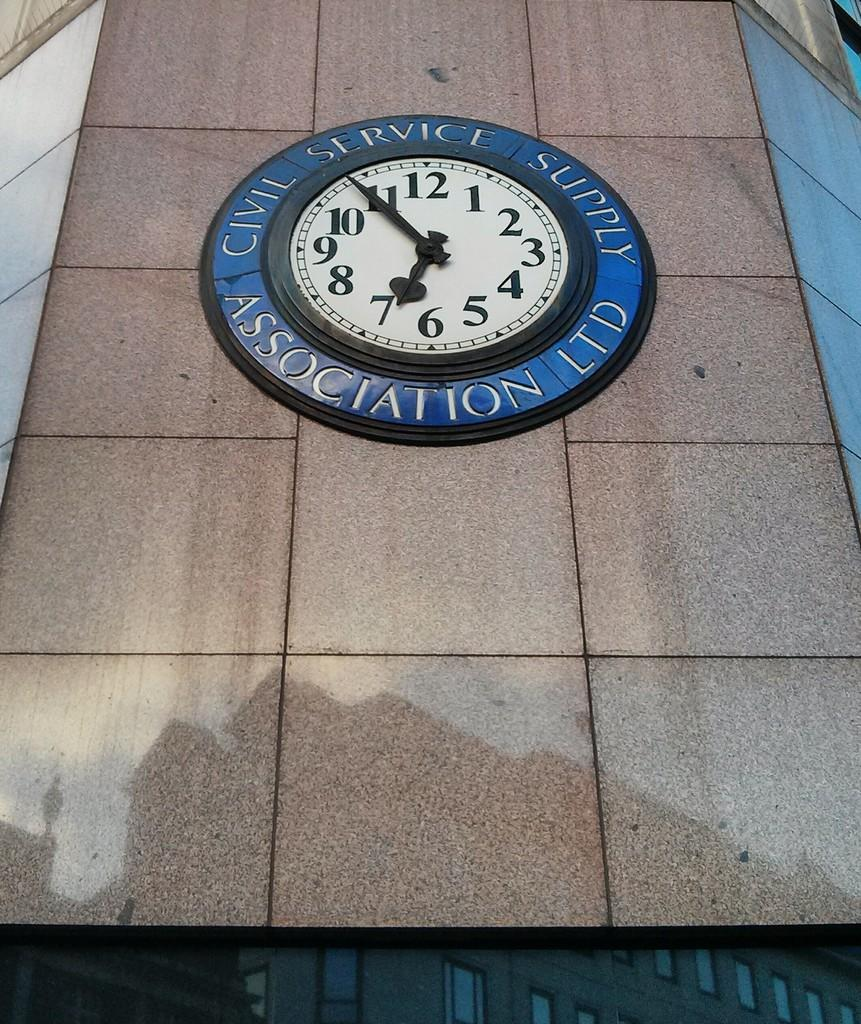<image>
Offer a succinct explanation of the picture presented. A clock on a building's wall that reads civil service supply association LTD 